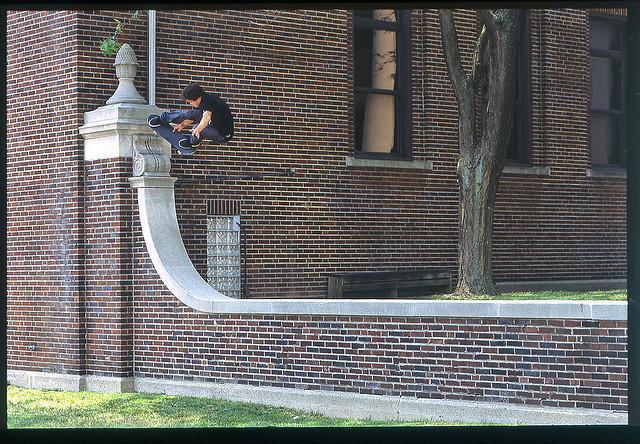How many children do you see?
Give a very brief answer. 1. How many hot dogs are there?
Give a very brief answer. 0. 